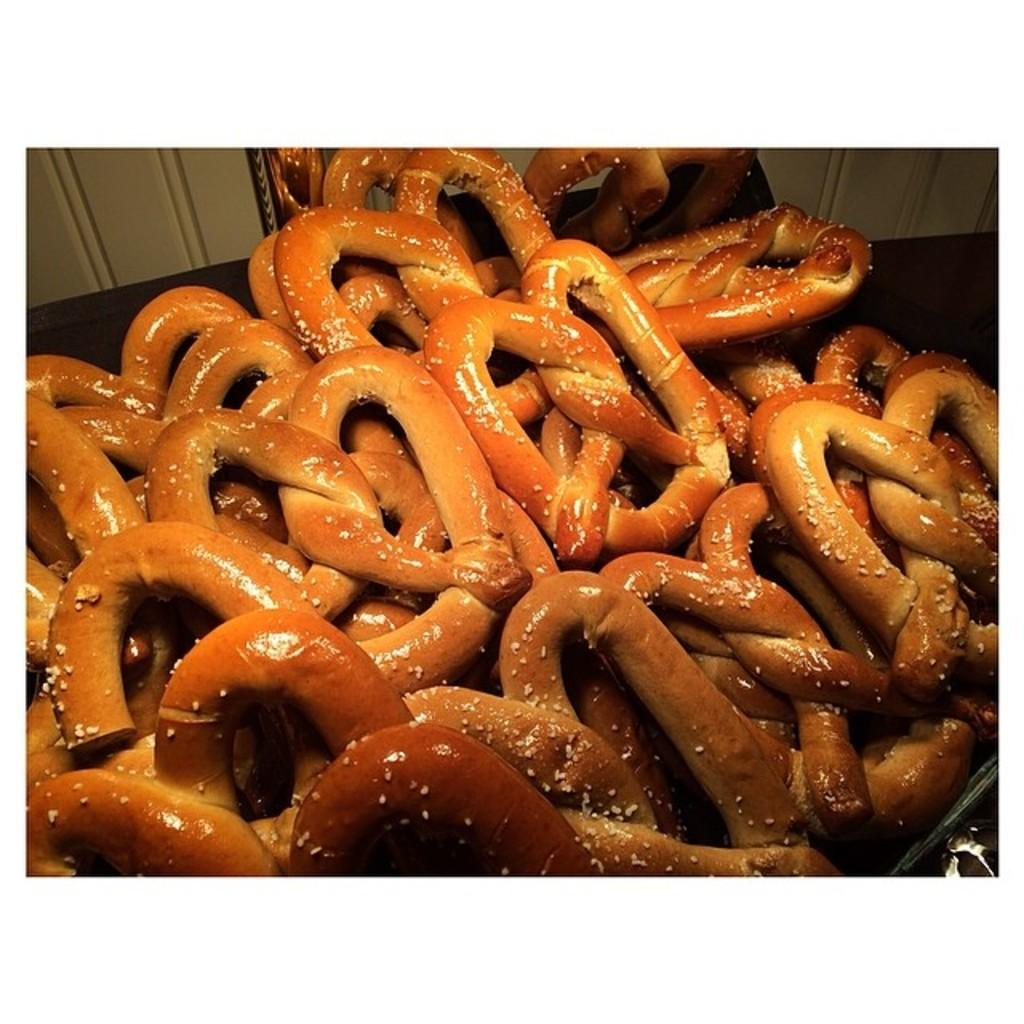What type of items can be seen in the image? There are food items in the image. Where are the food items located? The food items are on an object. What else can be seen in the image besides the food items? There is a wall visible in the image. What type of cough medicine is being used by the army in the image? There is no cough medicine or army present in the image; it features food items on an object with a visible wall. 